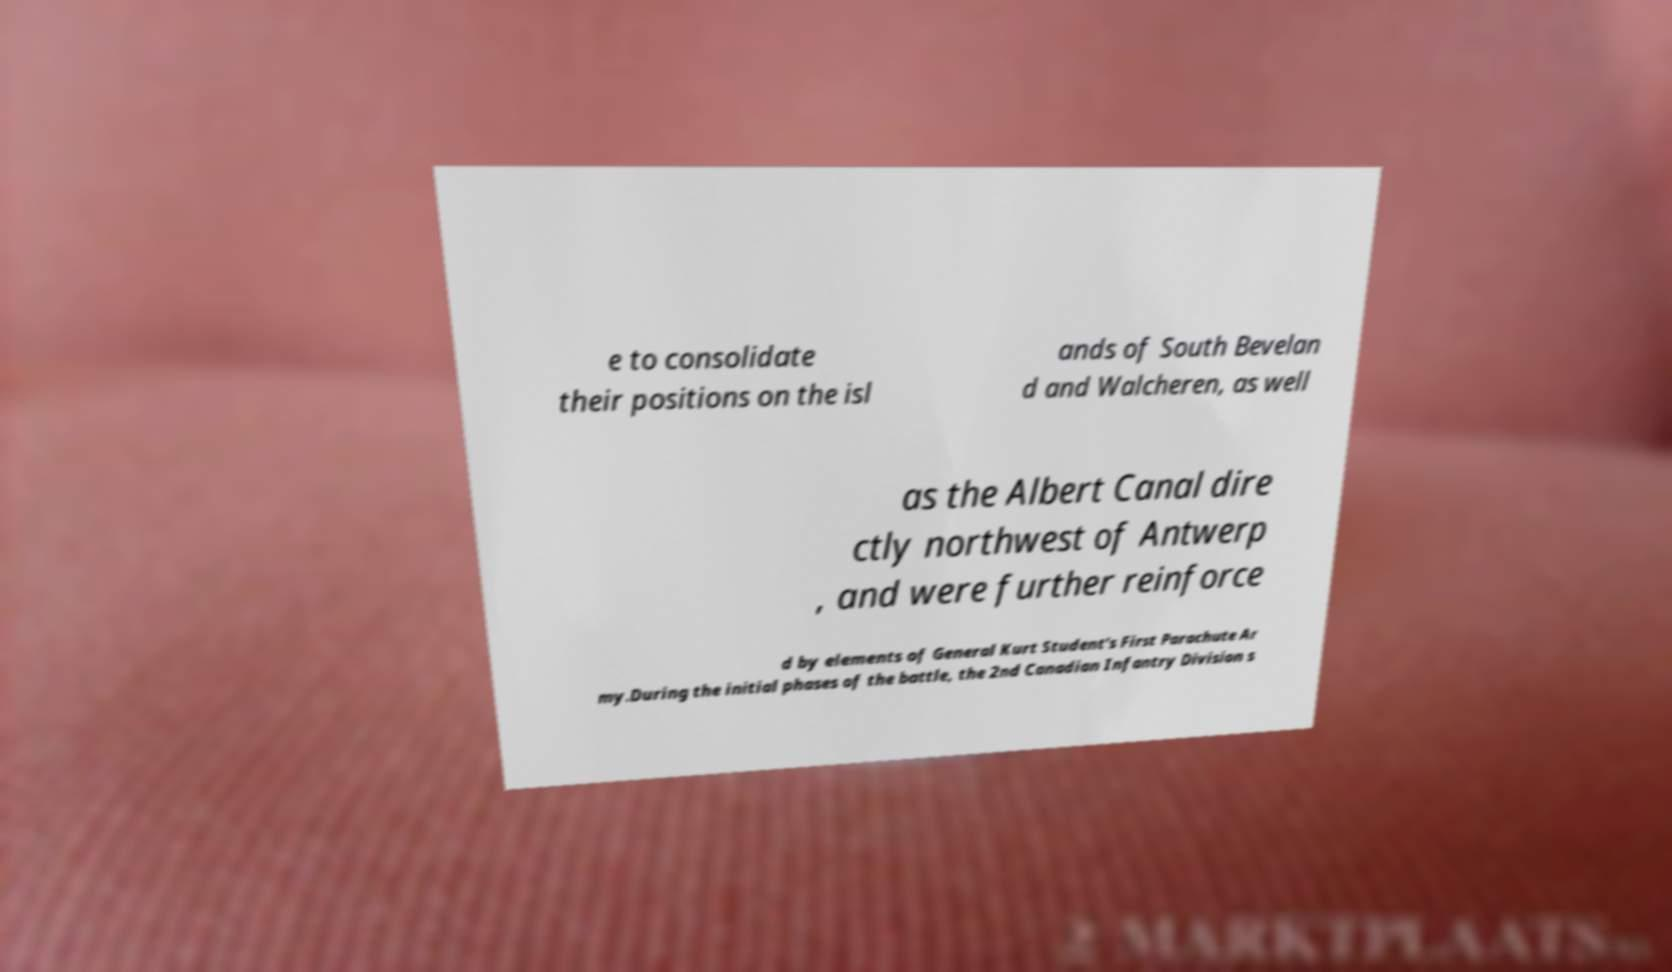What messages or text are displayed in this image? I need them in a readable, typed format. e to consolidate their positions on the isl ands of South Bevelan d and Walcheren, as well as the Albert Canal dire ctly northwest of Antwerp , and were further reinforce d by elements of General Kurt Student's First Parachute Ar my.During the initial phases of the battle, the 2nd Canadian Infantry Division s 